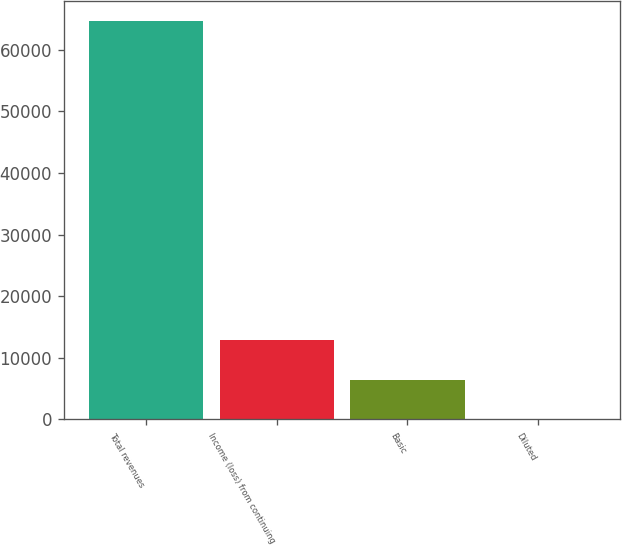<chart> <loc_0><loc_0><loc_500><loc_500><bar_chart><fcel>Total revenues<fcel>Income (loss) from continuing<fcel>Basic<fcel>Diluted<nl><fcel>64680<fcel>12938.9<fcel>6471.21<fcel>3.57<nl></chart> 